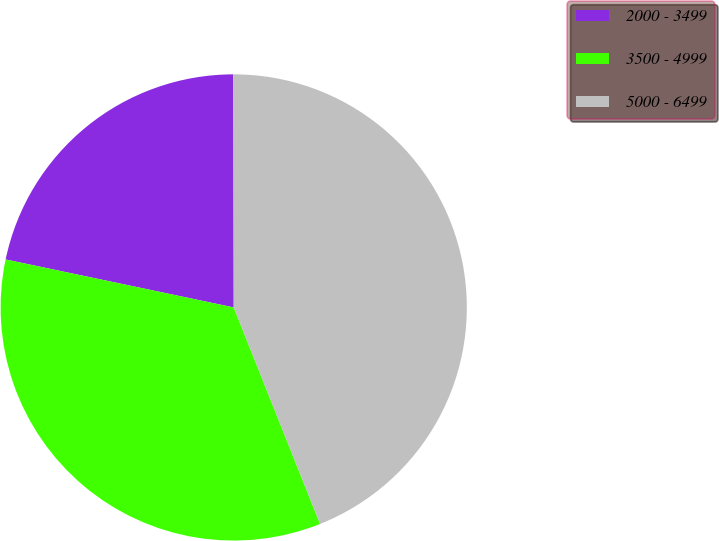Convert chart to OTSL. <chart><loc_0><loc_0><loc_500><loc_500><pie_chart><fcel>2000 - 3499<fcel>3500 - 4999<fcel>5000 - 6499<nl><fcel>21.67%<fcel>34.34%<fcel>43.99%<nl></chart> 